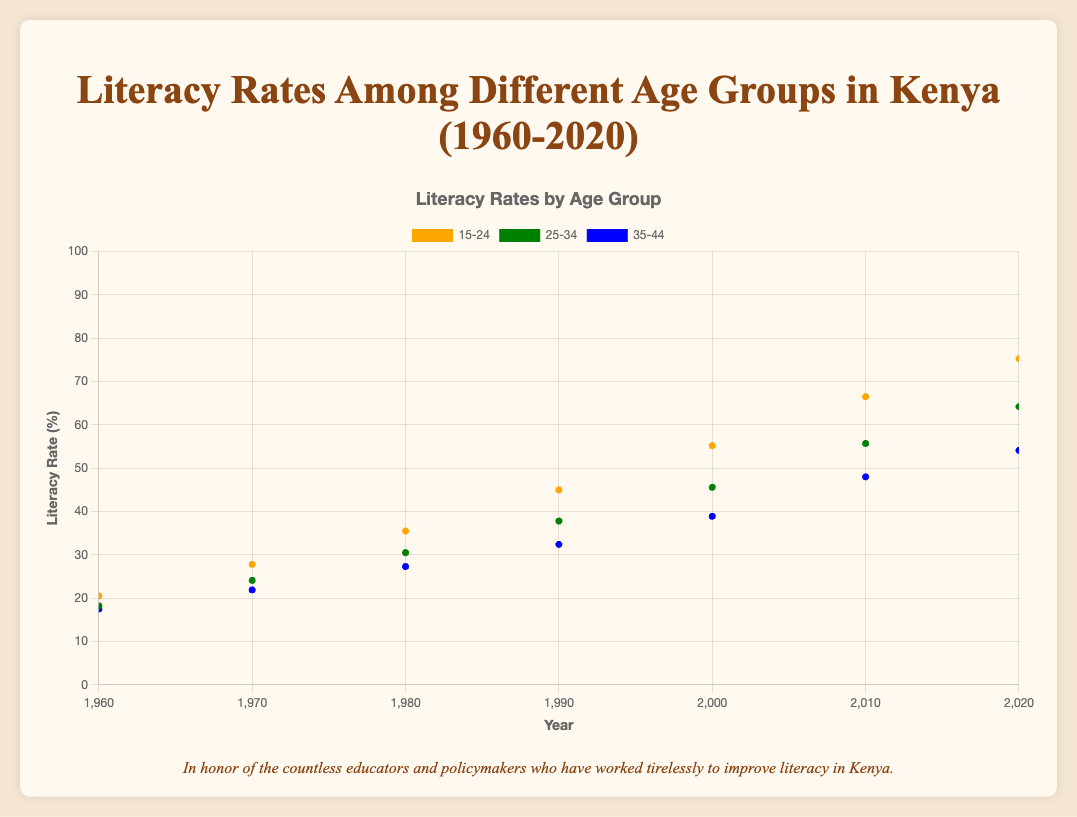What is the title of the figure? The title is usually displayed at the top of the figure and provides a summary of what the figure is about.
Answer: Literacy Rates Among Different Age Groups in Kenya (1960-2020) What does the x-axis represent? The x-axis, typically at the bottom of the chart, indicates the horizontal dimension and provides context for the data points along this dimension.
Answer: Year What does the y-axis represent? The y-axis, typically on the left side of the chart, indicates the vertical dimension and provides context for the data points along this dimension.
Answer: Literacy Rate (%) Which age group had the highest literacy rate in 2020? By looking at the points plotted for the year 2020, you can see which age group has the highest value on the y-axis.
Answer: 15-24 What similarity can you observe in the trend lines of all age groups over the entire period? By examining the trend of each colored line over time, you can observe a pattern or similarity in their trajectories.
Answer: All age groups show an upward trend in literacy rates over time Which age group had the lowest literacy rate in 1960? Locate the data points or trend lines corresponding to the year 1960 and compare the values on the y-axis.
Answer: 35-44 By how much did the literacy rate for the age group 15-24 increase from 1960 to 2020? Subtract the literacy rate in 1960 from the literacy rate in 2020 for the age group 15-24.
Answer: 54.8% Between which years did the age group 25-34 see the largest increase in literacy rates? Identify the years between which the most significant vertical change occurs for the 25-34 age group's trend line.
Answer: 2000 to 2010 How does the literacy rate of the 35-44 age group in 1990 compare to the 25-34 age group in 1980? Locate and compare the data points for these specific years and age groups on the y-axis.
Answer: The literacy rate of the 35-44 age group in 1990 (32.4%) is slightly higher than that of the 25-34 age group in 1980 (30.5%) Is there any age group that has a declining literacy rate at any point in time? Observe the trend lines closely to see if there is any age group where the line goes downward at any point.
Answer: No, all age groups have either stable or increasing trends in literacy rates over time 